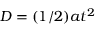<formula> <loc_0><loc_0><loc_500><loc_500>D = ( 1 / 2 ) a t ^ { 2 }</formula> 